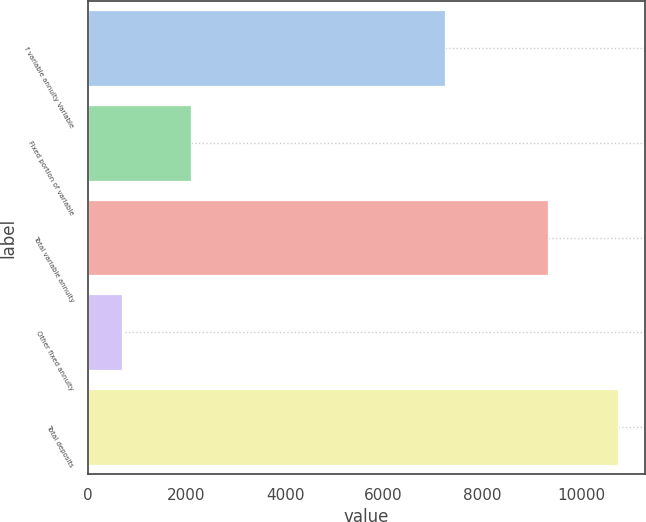<chart> <loc_0><loc_0><loc_500><loc_500><bar_chart><fcel>f variable annuity Variable<fcel>Fixed portion of variable<fcel>Total variable annuity<fcel>Other fixed annuity<fcel>Total deposits<nl><fcel>7251<fcel>2090<fcel>9341<fcel>698<fcel>10756<nl></chart> 